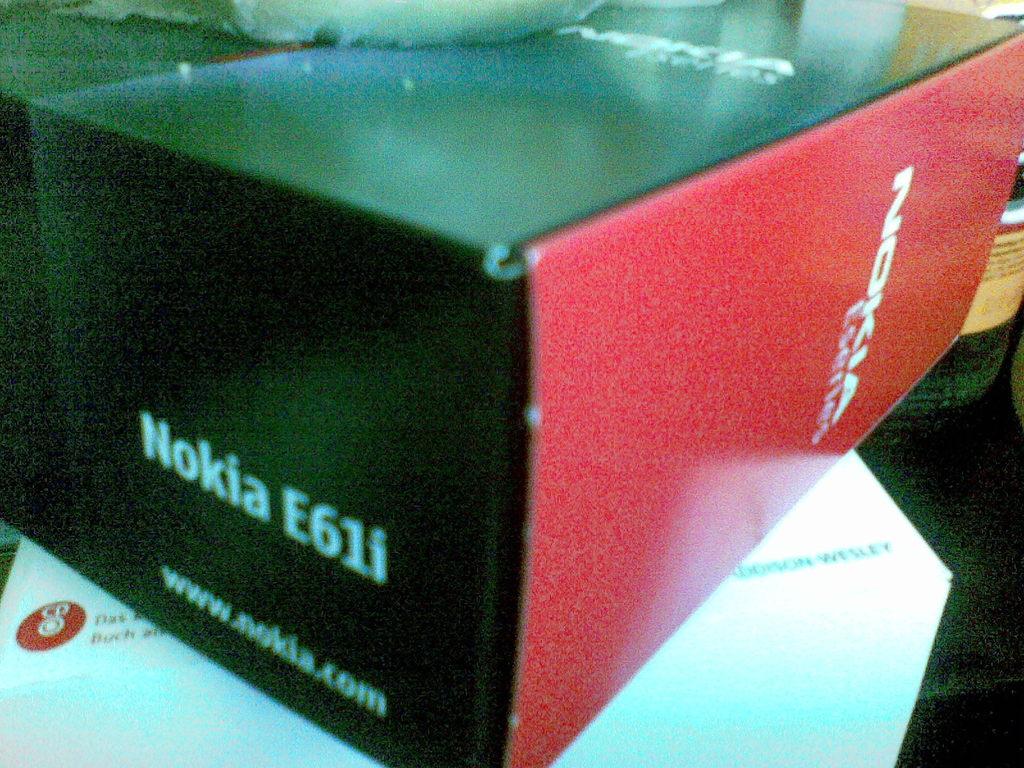What is the model of the nokia phone?
Give a very brief answer. E61i. 